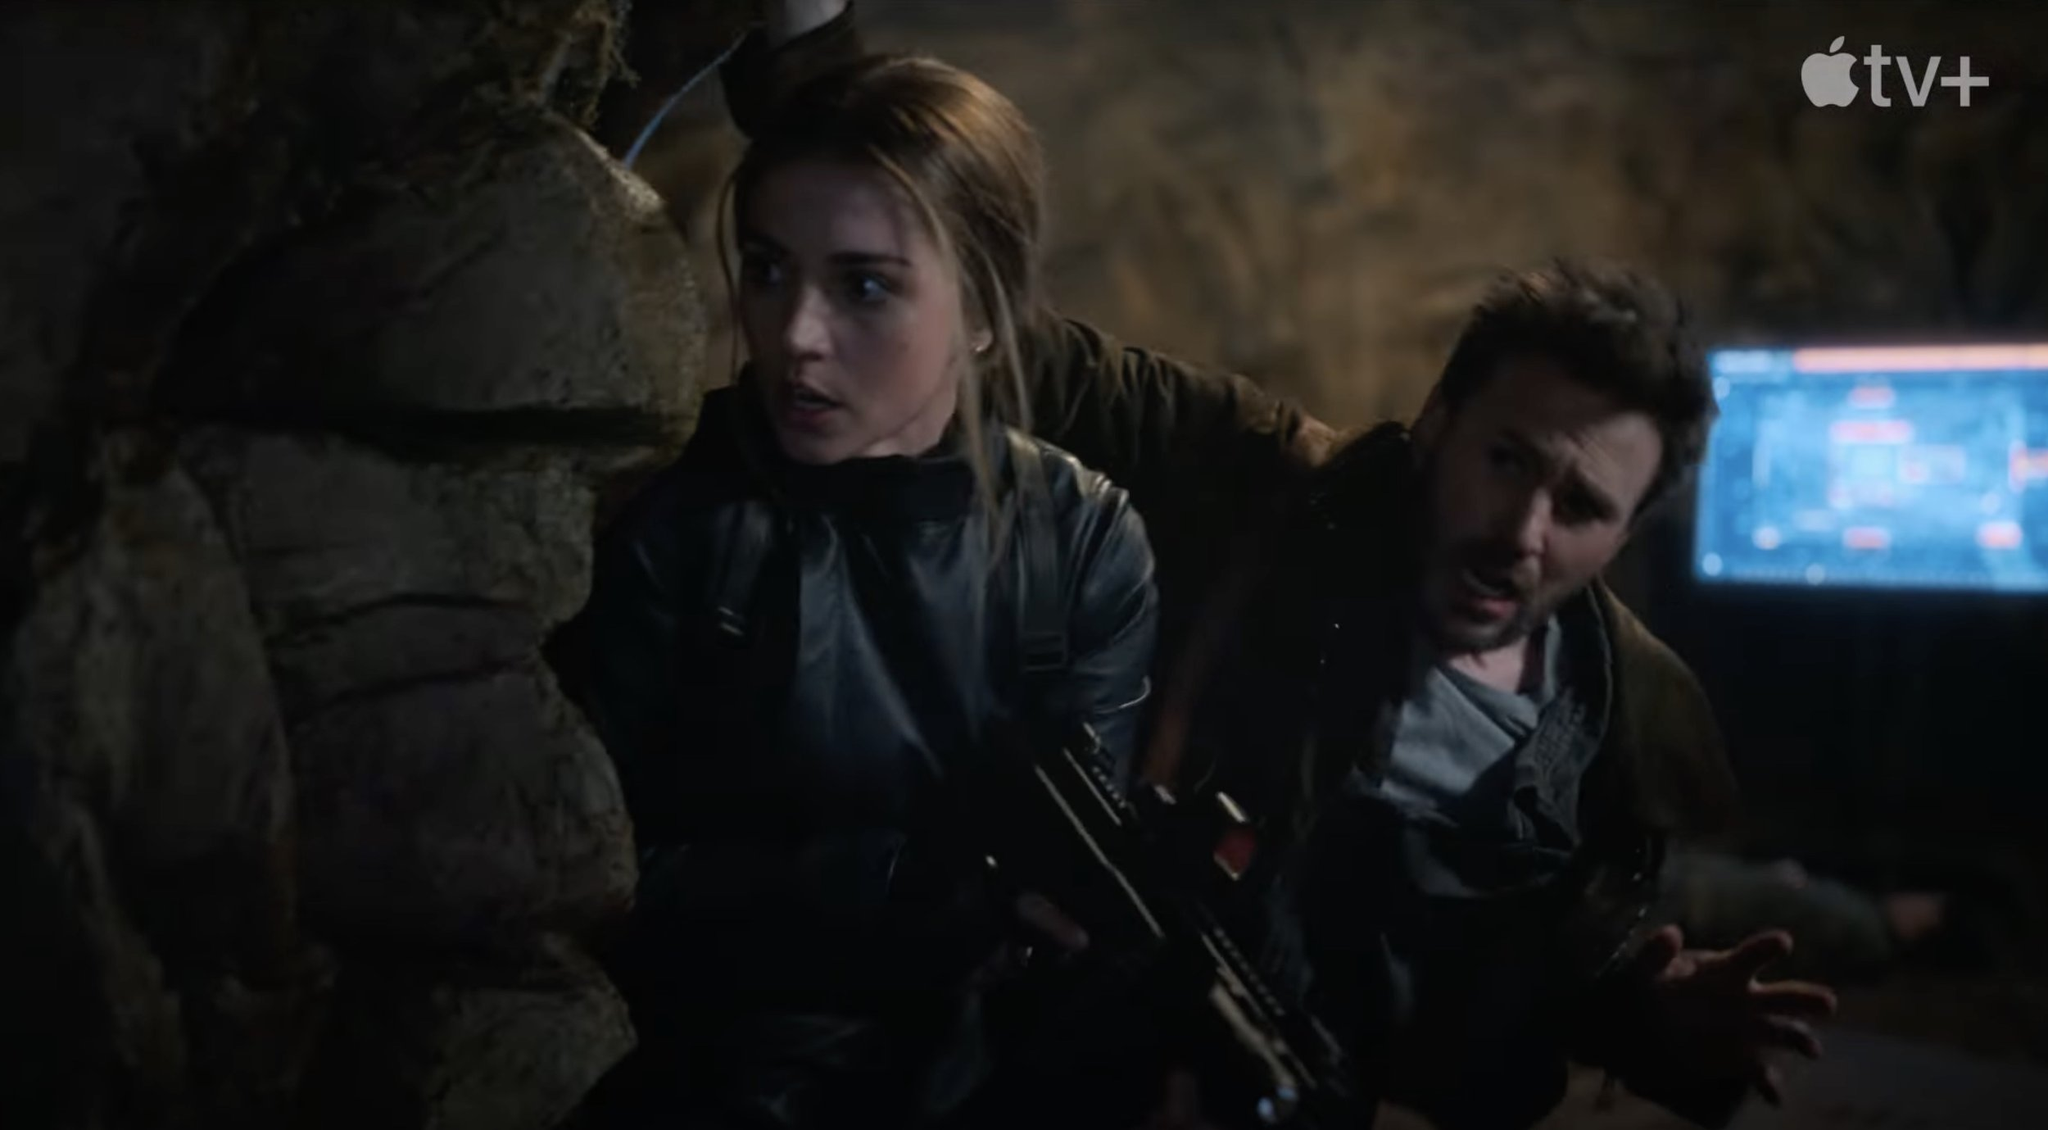What are the characters preparing for? The characters appear to be bracing themselves for a confrontation or an ambush. Their expressions and body language indicate high alertness and readiness to respond quickly to any threat. The weapons they hold suggest they are expecting a potential threat that could require immediate defensive action. The surroundings, which look like a cave or a secret lair, along with the computer screen in the background, hint at a larger plan or mission that may involve technology and stealth. What might the computer screen be displaying in the background? The computer screen in the background likely displays critical information pertinent to their mission. It could be showing a map of the area, surveillance footage, or vital data regarding their target. The digital interface and glowing marks suggest it is a high-tech device used for real-time monitoring or to access sensitive information that is crucial to their operation. 